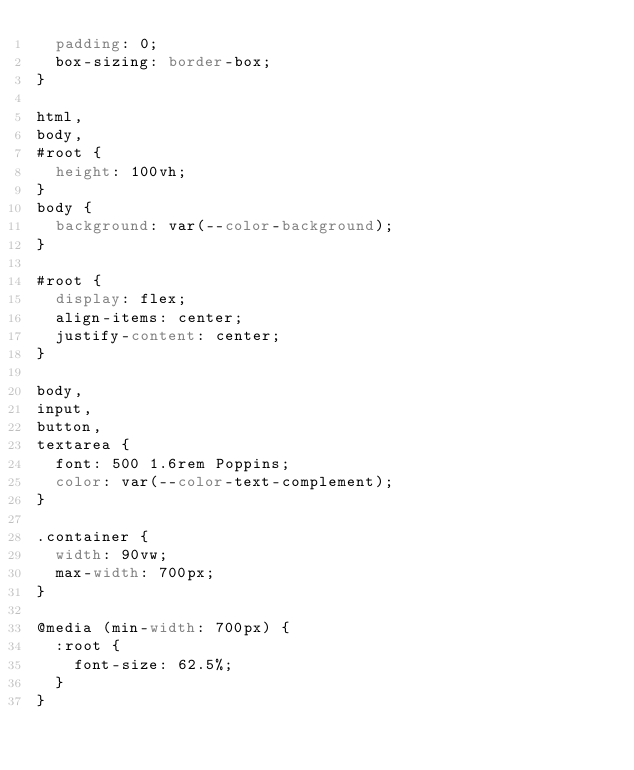<code> <loc_0><loc_0><loc_500><loc_500><_CSS_>  padding: 0;
  box-sizing: border-box;
}

html,
body,
#root {
  height: 100vh;
}
body {
  background: var(--color-background);
}

#root {
  display: flex;
  align-items: center;
  justify-content: center;
}

body,
input,
button,
textarea {
  font: 500 1.6rem Poppins;
  color: var(--color-text-complement);
}

.container {
  width: 90vw;
  max-width: 700px;
}

@media (min-width: 700px) {
  :root {
    font-size: 62.5%;
  }
}
</code> 